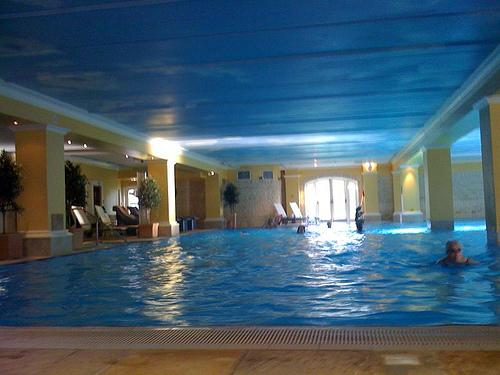Where are the potted trees located in the image? The potted trees are lining the side of a swimming pool. Please provide a detailed description of the indoor swimming pool area. The indoor swimming pool has blue water, recessed lighting in the ceiling, a blue ceiling with reflections, white lounge chairs on the side, and potted trees by yellow columns. There are people swimming in the pool and a door to the outside. Provide an overall sentiment evaluation of the image. The image has a positive and relaxing sentiment with people enjoying an indoor swimming pool surrounded by potted trees and lounge chairs. What objects are interacting with the swimming pool water? People swimming and the reflections of light on the water are interacting with the swimming pool water. List the items found on both sides of the pool. White lounge chairs, potted trees by yellow columns, and chairs beside the doors are on the sides of the pool. Count the total number of people in the swimming pool. There are 5 people swimming in the pool. Describe the color scheme of the indoor pool area. The color scheme includes blue water and ceiling, white lounge chairs and trim, yellow columns, neutral-colored pillars, and green potted trees. Assess the quality of the image by describing the clarity and visibility of objects. The image quality is high, with clear visibility and detailed descriptions of objects such as people, trees, chairs, and lighting elements. Identify the most prominent light source in the image. Sunshine shining through a large window. Can you spot a lifeguard sitting on a tall chair near the pool? No, it's not mentioned in the image. Describe the relationship between the potted trees and the swimming pool. The potted trees are lining the side of the swimming pool. Evaluate the quality of the image based on the object's visibility and distinction. The image has high quality with clear visibility and distinct object detail. Identify the objects next to the yellow columns. Plants Analyze the interaction between the people and the pool in the image. People are swimming and enjoying the indoor pool. Describe the scene in this image with the given information. An indoor swimming pool with blue water, sunshine shining through a large window, potted trees, lounge chairs, older people swimming, pillars, and light fixtures. How many people are swimming in this pool? There are at least four people swimming in the pool. Does the overall image depict a positive or negative sentiment? The image depicts a positive sentiment. Determine the color and size of the ceiling in the image. The ceiling is blue and has a size of Width:485 and Height:485. What colors are dominant in this indoor swimming pool setting? Blue and white are the dominant colors. Is there any item of a red color, and if so, where is it located? Yes, there is a red item hanging on the wall at X:357, Y:185. What material is the tread on the swimming pool border made of? Not enough information provided to determine the material. Identify the shape of the light fixture on the wall. Insufficient information to determine the shape of the light fixture. Identify any text or symbols visible in the image. No text or symbols detected. Which objects are the reflection of light visible on? The reflection of light is visible on the water and the ceiling. Which objects are closest to the door to the outside? Chairs beside the doors are closest to the door to the outside. What objects surround the swimming pool in this image? Lounge chairs, plants near yellow columns, a drain, handrails, and a window. Detect any unusual or unexpected aspect of the image. No anomalies detected, all objects are consistent with an indoor pool environment. Can you identify any safety features near the swimming pool? Handrails and a drain by the pool are safety features. Look for a purple beach ball floating in the pool. There is no mention of a beach ball in the list of objects, let alone any specific color beach ball. This instruction is misleading since it directs the searcher to find a nonexistent object in the image. 